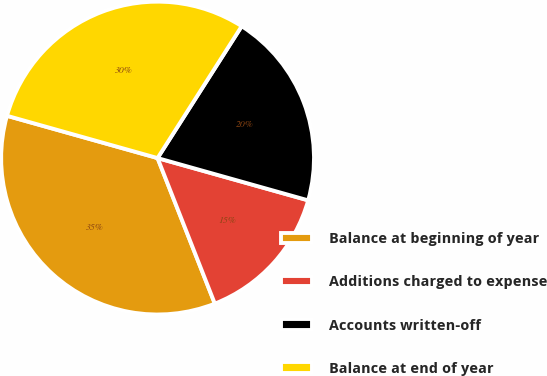<chart> <loc_0><loc_0><loc_500><loc_500><pie_chart><fcel>Balance at beginning of year<fcel>Additions charged to expense<fcel>Accounts written-off<fcel>Balance at end of year<nl><fcel>35.32%<fcel>14.68%<fcel>20.32%<fcel>29.68%<nl></chart> 